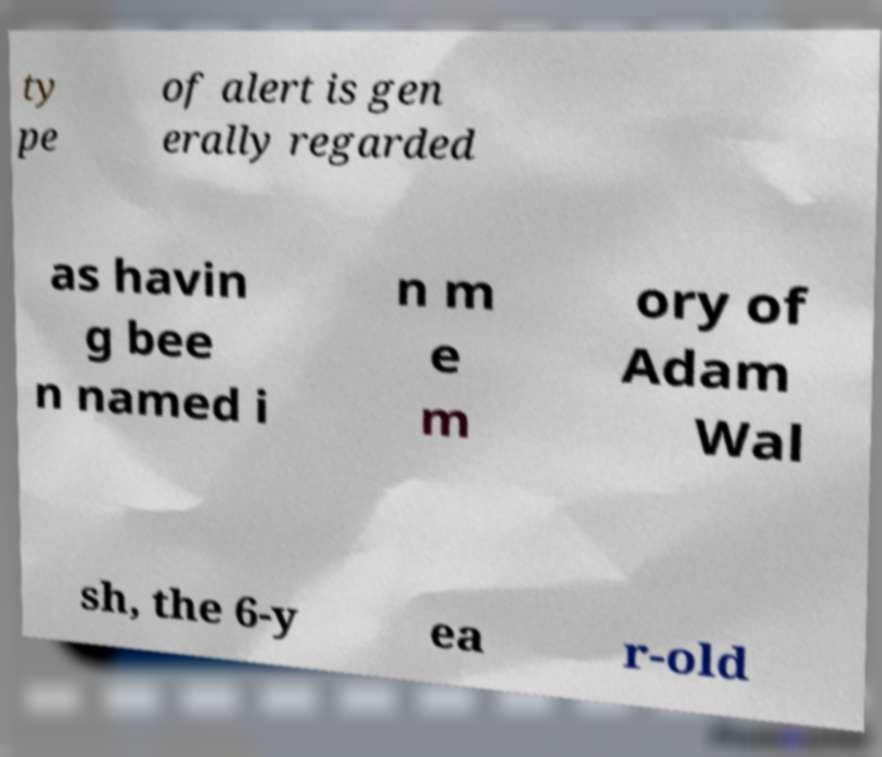I need the written content from this picture converted into text. Can you do that? ty pe of alert is gen erally regarded as havin g bee n named i n m e m ory of Adam Wal sh, the 6-y ea r-old 